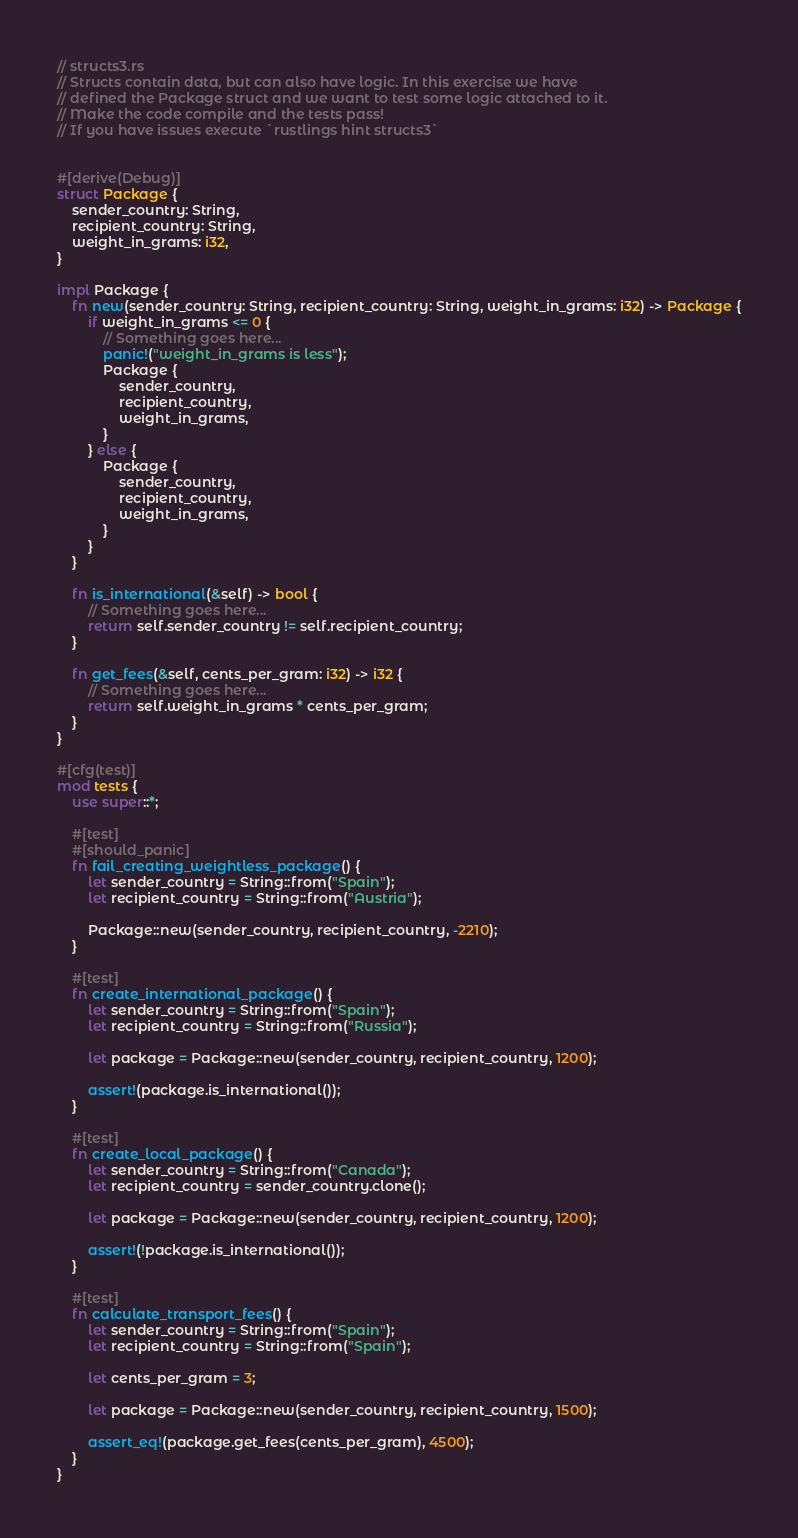<code> <loc_0><loc_0><loc_500><loc_500><_Rust_>// structs3.rs
// Structs contain data, but can also have logic. In this exercise we have
// defined the Package struct and we want to test some logic attached to it.
// Make the code compile and the tests pass!
// If you have issues execute `rustlings hint structs3`


#[derive(Debug)]
struct Package {
    sender_country: String,
    recipient_country: String,
    weight_in_grams: i32,
}

impl Package {
    fn new(sender_country: String, recipient_country: String, weight_in_grams: i32) -> Package {
        if weight_in_grams <= 0 {
            // Something goes here...
            panic!("weight_in_grams is less");
            Package {
                sender_country,
                recipient_country,
                weight_in_grams,
            }
        } else {
            Package {
                sender_country,
                recipient_country,
                weight_in_grams,
            }
        }
    }

    fn is_international(&self) -> bool {
        // Something goes here...
        return self.sender_country != self.recipient_country;
    }

    fn get_fees(&self, cents_per_gram: i32) -> i32 {
        // Something goes here...
        return self.weight_in_grams * cents_per_gram;
    }
}

#[cfg(test)]
mod tests {
    use super::*;

    #[test]
    #[should_panic]
    fn fail_creating_weightless_package() {
        let sender_country = String::from("Spain");
        let recipient_country = String::from("Austria");

        Package::new(sender_country, recipient_country, -2210);
    }

    #[test]
    fn create_international_package() {
        let sender_country = String::from("Spain");
        let recipient_country = String::from("Russia");

        let package = Package::new(sender_country, recipient_country, 1200);

        assert!(package.is_international());
    }

    #[test]
    fn create_local_package() {
        let sender_country = String::from("Canada");
        let recipient_country = sender_country.clone();

        let package = Package::new(sender_country, recipient_country, 1200);

        assert!(!package.is_international());
    }

    #[test]
    fn calculate_transport_fees() {
        let sender_country = String::from("Spain");
        let recipient_country = String::from("Spain");

        let cents_per_gram = 3;

        let package = Package::new(sender_country, recipient_country, 1500);

        assert_eq!(package.get_fees(cents_per_gram), 4500);
    }
}
</code> 